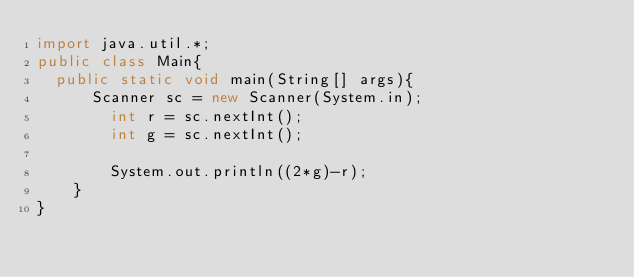Convert code to text. <code><loc_0><loc_0><loc_500><loc_500><_Java_>import java.util.*;
public class Main{
	public static void main(String[] args){
    	Scanner sc = new Scanner(System.in);
      	int r = sc.nextInt();
      	int g = sc.nextInt();
	   	
      	System.out.println((2*g)-r);
    }
}</code> 